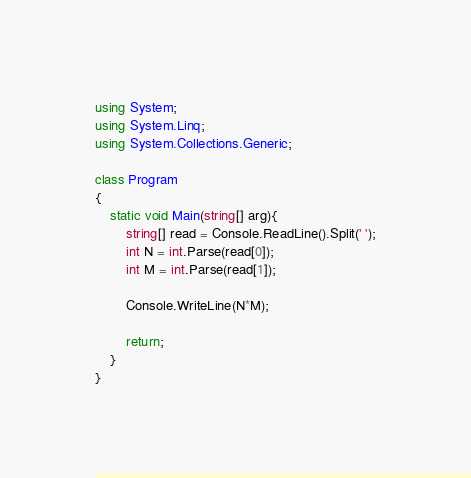Convert code to text. <code><loc_0><loc_0><loc_500><loc_500><_C#_>using System;
using System.Linq;
using System.Collections.Generic;

class Program
{
    static void Main(string[] arg){
        string[] read = Console.ReadLine().Split(' ');
        int N = int.Parse(read[0]);
        int M = int.Parse(read[1]);

        Console.WriteLine(N*M);

        return;
    }
}
</code> 